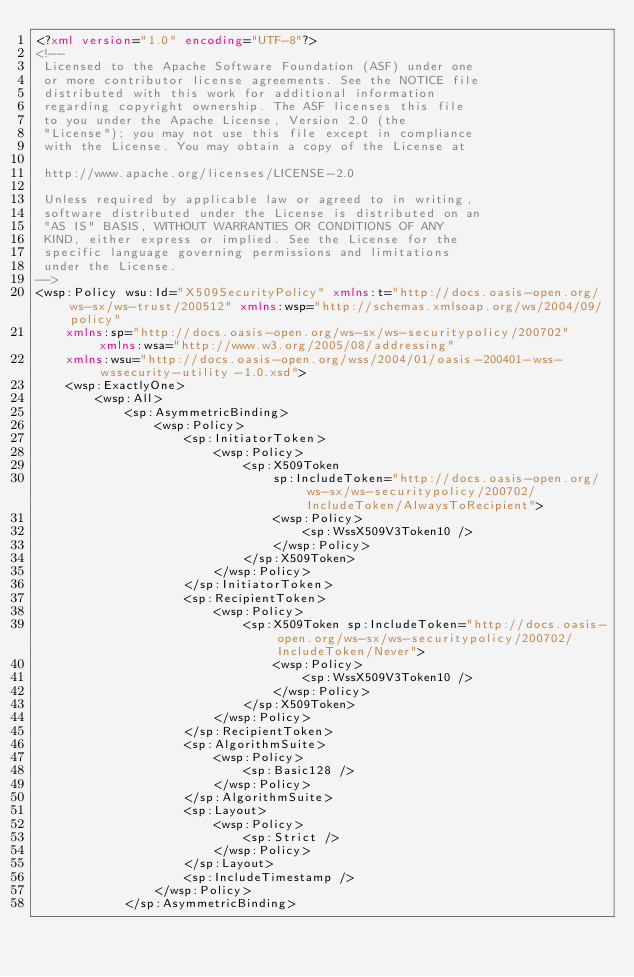<code> <loc_0><loc_0><loc_500><loc_500><_XML_><?xml version="1.0" encoding="UTF-8"?>
<!--
 Licensed to the Apache Software Foundation (ASF) under one
 or more contributor license agreements. See the NOTICE file
 distributed with this work for additional information
 regarding copyright ownership. The ASF licenses this file
 to you under the Apache License, Version 2.0 (the
 "License"); you may not use this file except in compliance
 with the License. You may obtain a copy of the License at
 
 http://www.apache.org/licenses/LICENSE-2.0
 
 Unless required by applicable law or agreed to in writing,
 software distributed under the License is distributed on an
 "AS IS" BASIS, WITHOUT WARRANTIES OR CONDITIONS OF ANY
 KIND, either express or implied. See the License for the
 specific language governing permissions and limitations
 under the License.
-->
<wsp:Policy wsu:Id="X509SecurityPolicy" xmlns:t="http://docs.oasis-open.org/ws-sx/ws-trust/200512" xmlns:wsp="http://schemas.xmlsoap.org/ws/2004/09/policy"
    xmlns:sp="http://docs.oasis-open.org/ws-sx/ws-securitypolicy/200702" xmlns:wsa="http://www.w3.org/2005/08/addressing"
    xmlns:wsu="http://docs.oasis-open.org/wss/2004/01/oasis-200401-wss-wssecurity-utility-1.0.xsd">
    <wsp:ExactlyOne>
        <wsp:All>
            <sp:AsymmetricBinding>
                <wsp:Policy>
                    <sp:InitiatorToken>
                        <wsp:Policy>
                            <sp:X509Token
                                sp:IncludeToken="http://docs.oasis-open.org/ws-sx/ws-securitypolicy/200702/IncludeToken/AlwaysToRecipient">
                                <wsp:Policy>
                                    <sp:WssX509V3Token10 />
                                </wsp:Policy>
                            </sp:X509Token>
                        </wsp:Policy>
                    </sp:InitiatorToken>
                    <sp:RecipientToken>
                        <wsp:Policy>
                            <sp:X509Token sp:IncludeToken="http://docs.oasis-open.org/ws-sx/ws-securitypolicy/200702/IncludeToken/Never">
                                <wsp:Policy>
                                    <sp:WssX509V3Token10 />
                                </wsp:Policy>
                            </sp:X509Token>
                        </wsp:Policy>
                    </sp:RecipientToken>
                    <sp:AlgorithmSuite>
                        <wsp:Policy>
                            <sp:Basic128 />
                        </wsp:Policy>
                    </sp:AlgorithmSuite>
                    <sp:Layout>
                        <wsp:Policy>
                            <sp:Strict />
                        </wsp:Policy>
                    </sp:Layout>
                    <sp:IncludeTimestamp />
                </wsp:Policy>
            </sp:AsymmetricBinding></code> 